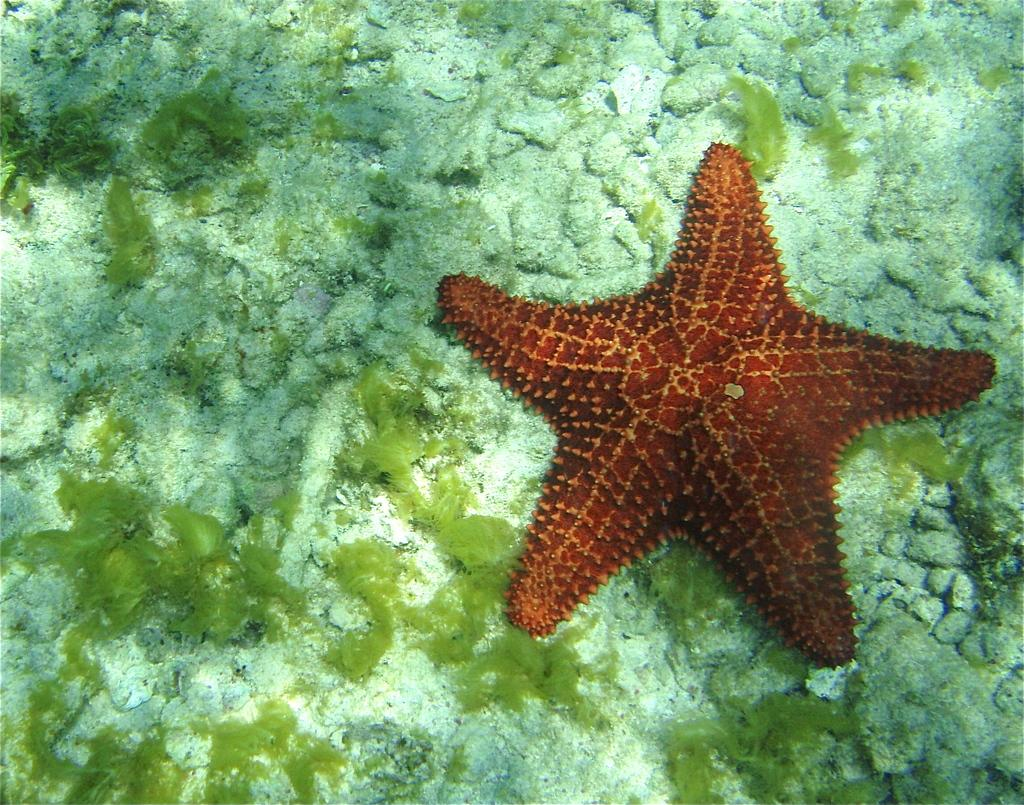What type of marine animal is present in the image? There is a starfish in the image. What other marine feature can be seen in the image? There is coral in the image. What type of fruit is hanging from the coral in the image? There is no fruit present in the image, and the coral is not depicted as having any fruit hanging from it. 